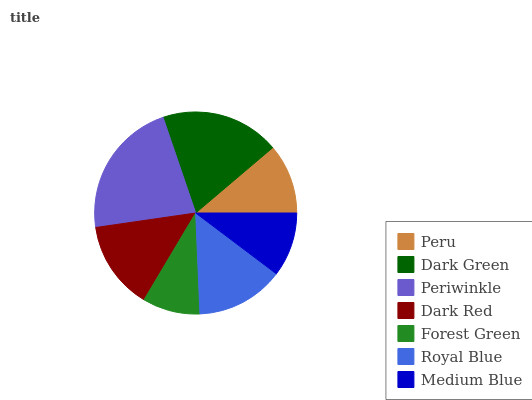Is Forest Green the minimum?
Answer yes or no. Yes. Is Periwinkle the maximum?
Answer yes or no. Yes. Is Dark Green the minimum?
Answer yes or no. No. Is Dark Green the maximum?
Answer yes or no. No. Is Dark Green greater than Peru?
Answer yes or no. Yes. Is Peru less than Dark Green?
Answer yes or no. Yes. Is Peru greater than Dark Green?
Answer yes or no. No. Is Dark Green less than Peru?
Answer yes or no. No. Is Royal Blue the high median?
Answer yes or no. Yes. Is Royal Blue the low median?
Answer yes or no. Yes. Is Peru the high median?
Answer yes or no. No. Is Peru the low median?
Answer yes or no. No. 